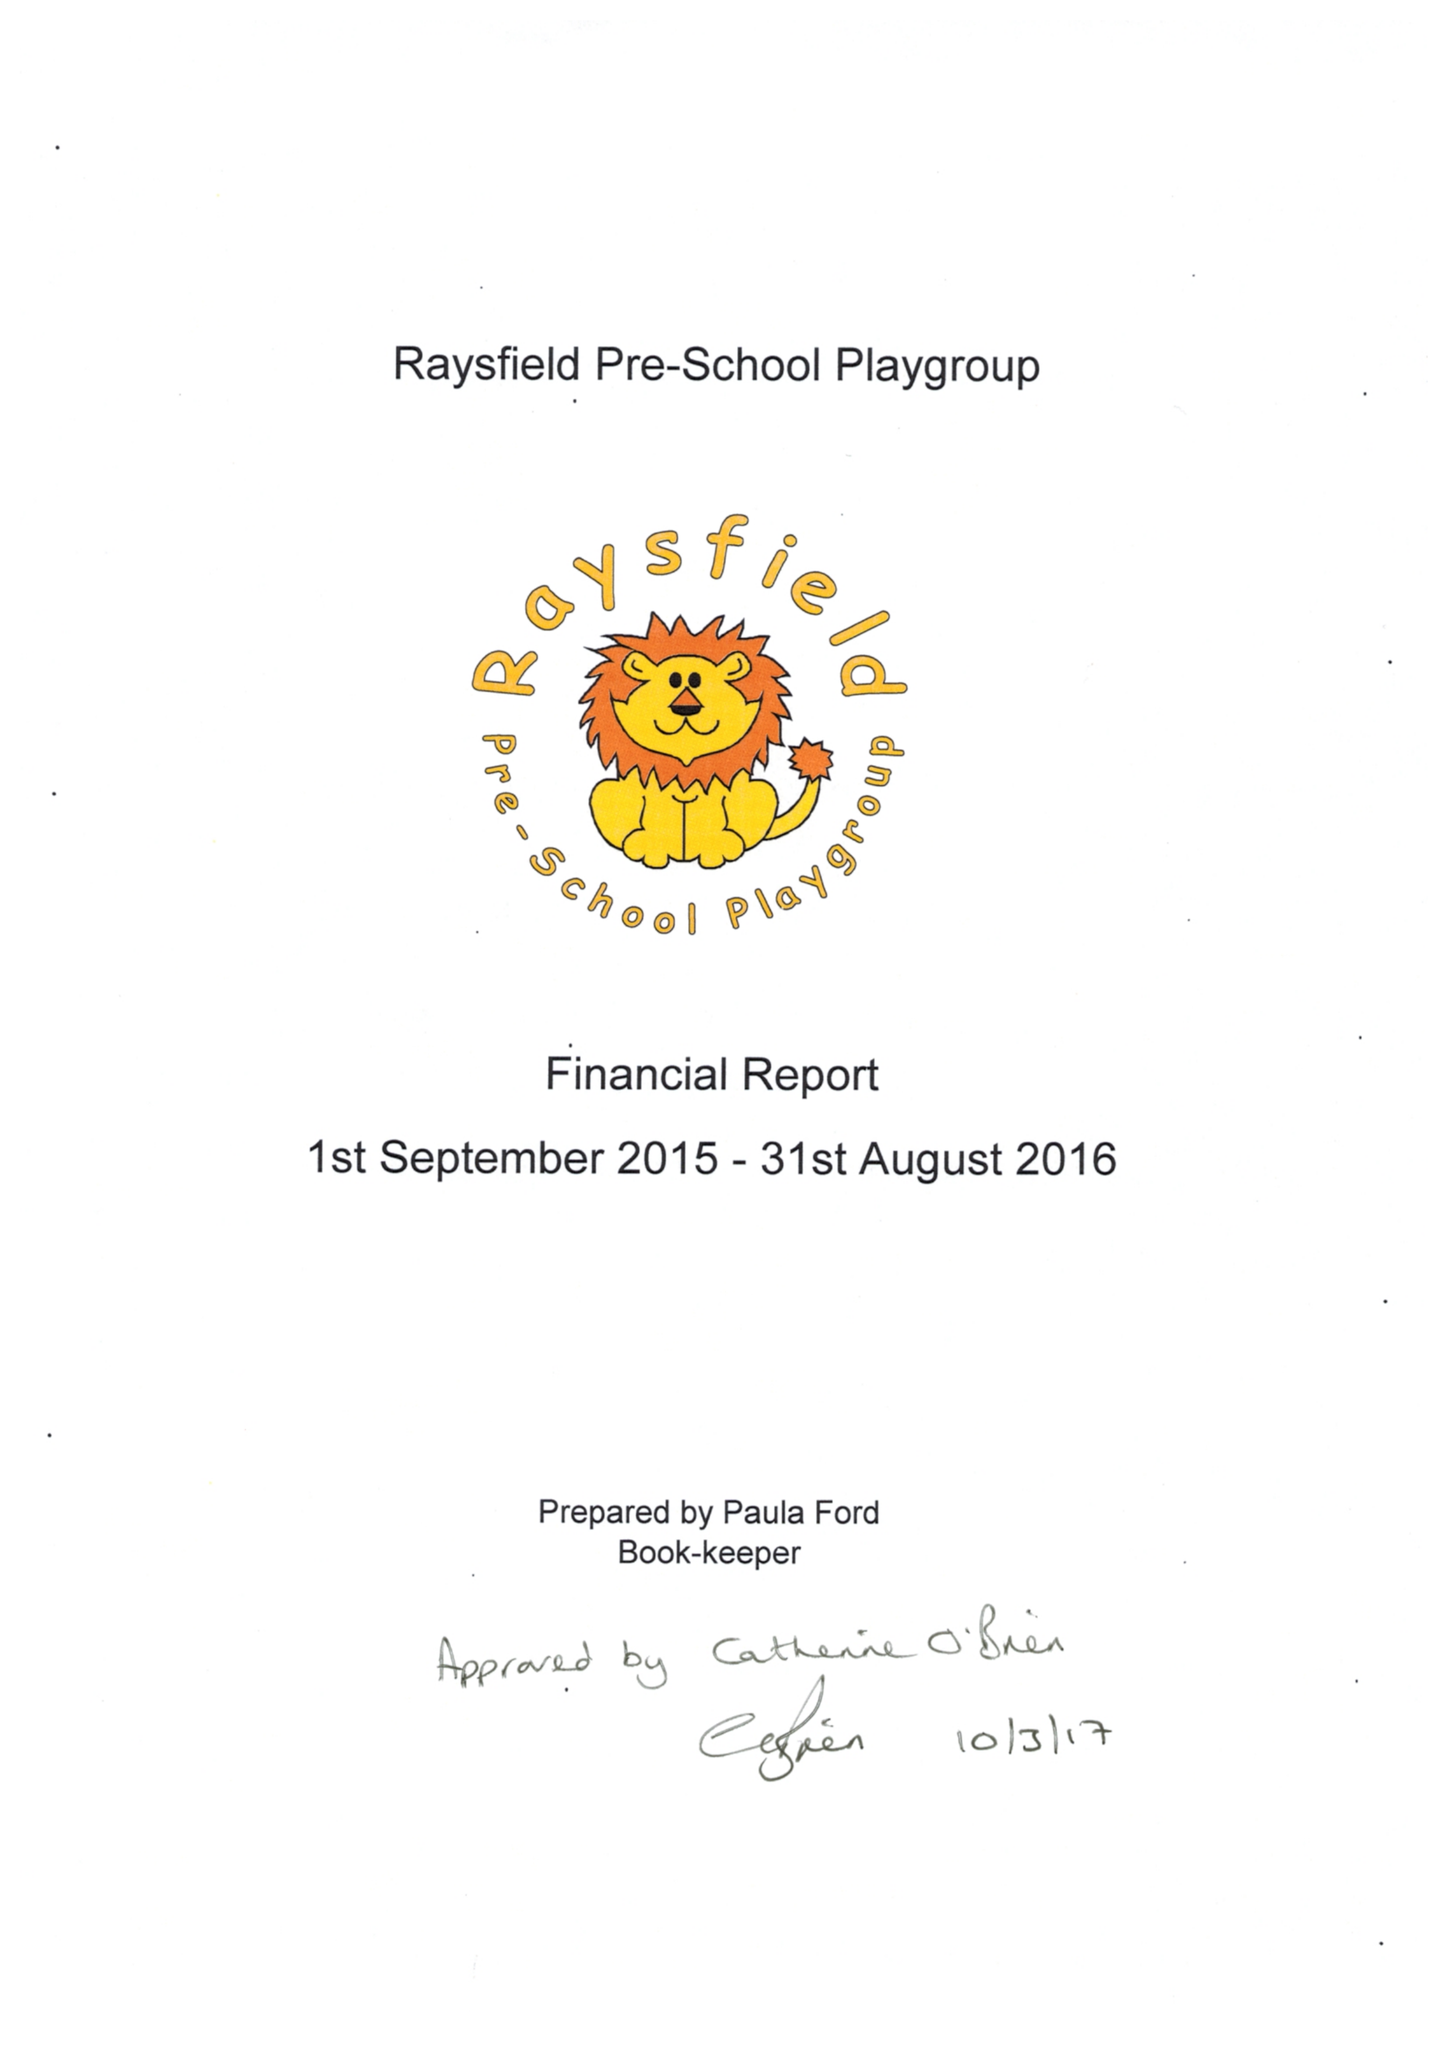What is the value for the address__street_line?
Answer the question using a single word or phrase. FINCH ROAD 